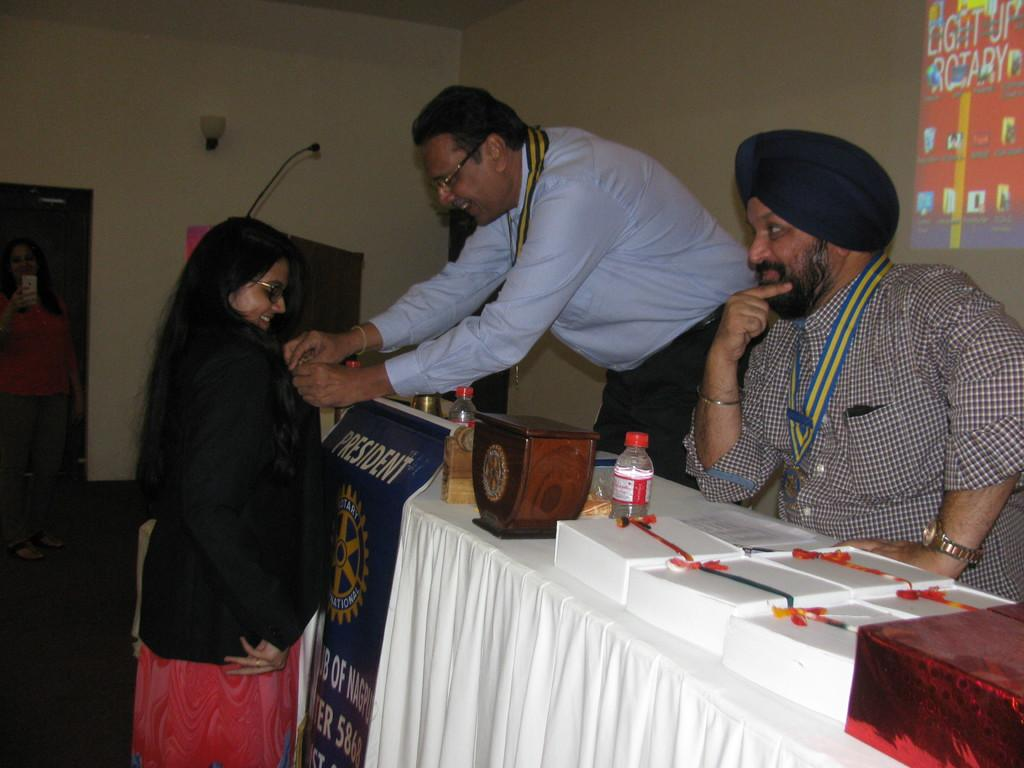<image>
Write a terse but informative summary of the picture. Two men sit at a table decorated with a banner reading "president" 